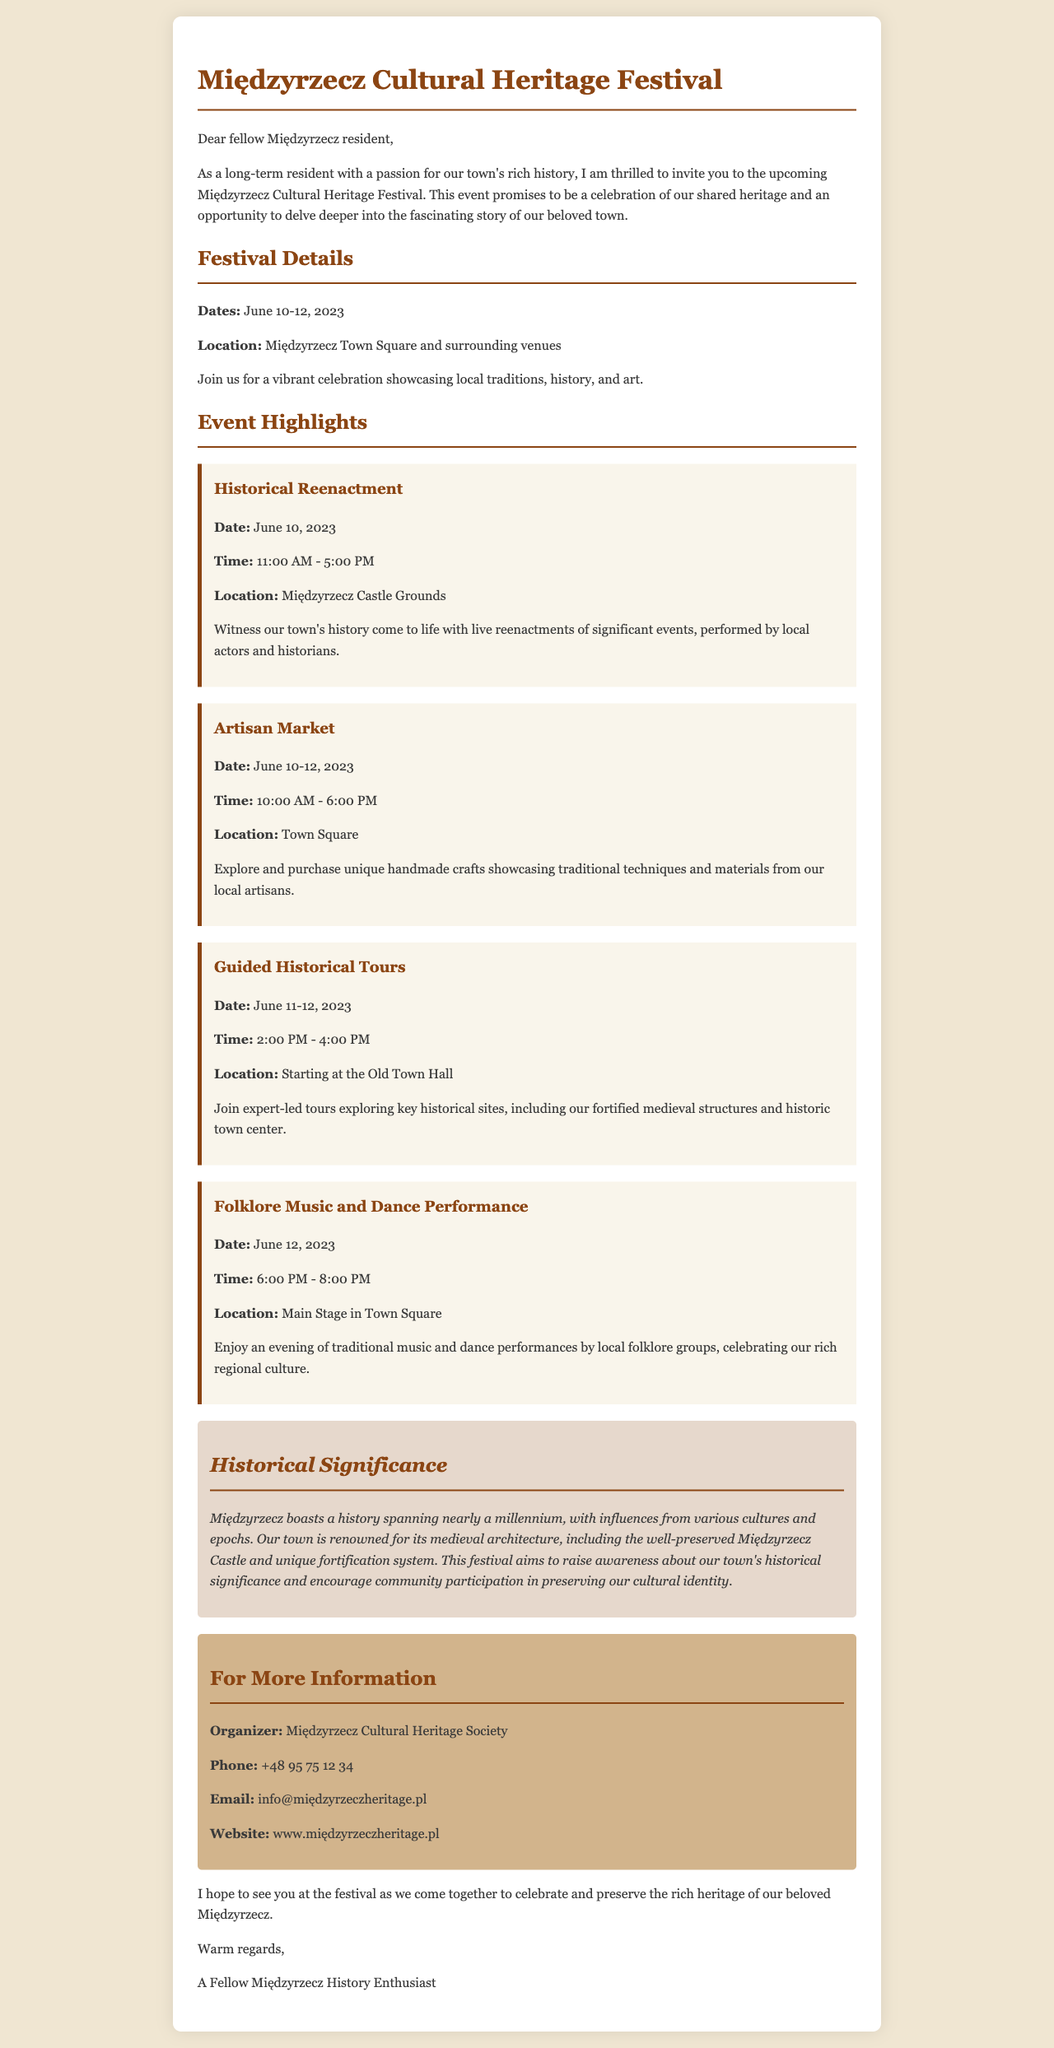what are the dates of the festival? The festival is scheduled to take place over three days, specifically from June 10 to 12, 2023.
Answer: June 10-12, 2023 where will the historical reenactment take place? The historical reenactment will be staged at a specific location mentioned in the document, which is the Międzyrzecz Castle Grounds.
Answer: Międzyrzecz Castle Grounds what time does the folklore music and dance performance start? The timing of the folklore music and dance performance is clearly stated in the document, beginning at 6:00 PM.
Answer: 6:00 PM how many events are highlighted in the document? By counting the unique event descriptions provided in the document, one can ascertain that there are four highlights listed.
Answer: Four what is the historical significance of Międzyrzecz mentioned in the document? The document discusses the notable history of Międzyrzecz, including its medieval architecture and fortifications, reflecting its importance that dates back nearly a millennium.
Answer: Nearly a millennium who is the organizer of the festival? The name of the organizing body for the festival is provided clearly, which is the Międzyrzecz Cultural Heritage Society.
Answer: Międzyrzecz Cultural Heritage Society when are the guided historical tours taking place? The document explicitly mentions the specific days and times for the guided historical tours, which are scheduled for June 11 and 12, 2023, from 2:00 PM to 4:00 PM.
Answer: June 11-12, 2023 what type of market is featured during the festival? The document describes one of the key attractions as a market showcasing local artisan crafts, which is referred to as the Artisan Market.
Answer: Artisan Market 